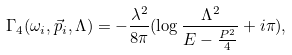Convert formula to latex. <formula><loc_0><loc_0><loc_500><loc_500>\Gamma _ { 4 } ( \omega _ { i } , \vec { p } _ { i } , \Lambda ) = - \frac { \lambda ^ { 2 } } { 8 \pi } ( \log \frac { \Lambda ^ { 2 } } { E - \frac { P ^ { 2 } } { 4 } } + i \pi ) ,</formula> 